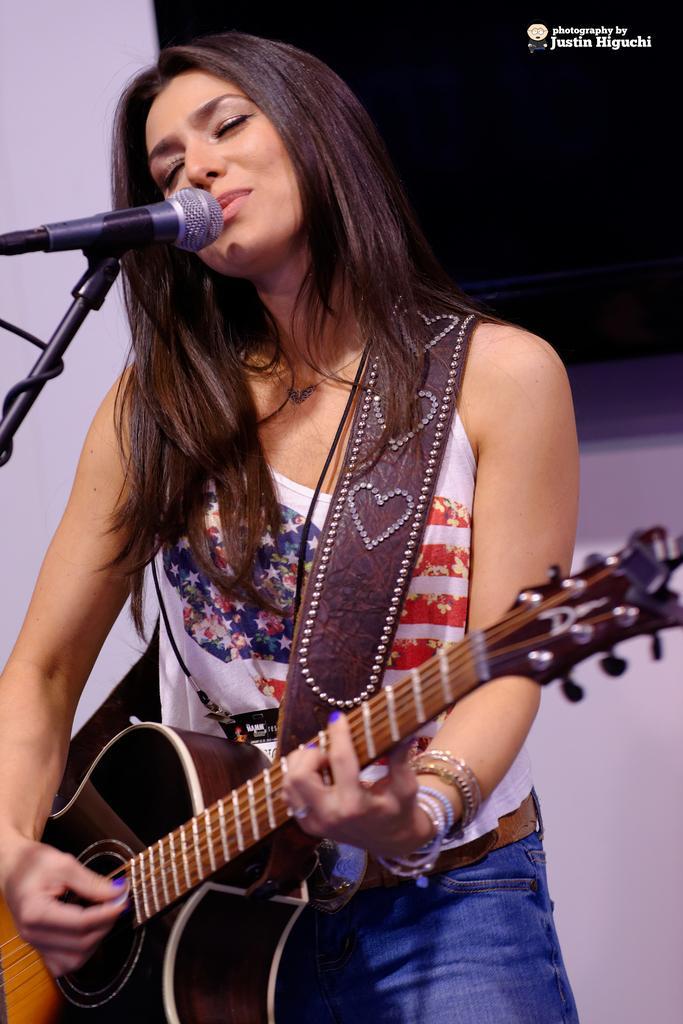Can you describe this image briefly? In this image, In the middle there is a woman she is holding a music instrument which is in black color and she is singing in the microphone which is in black color. 